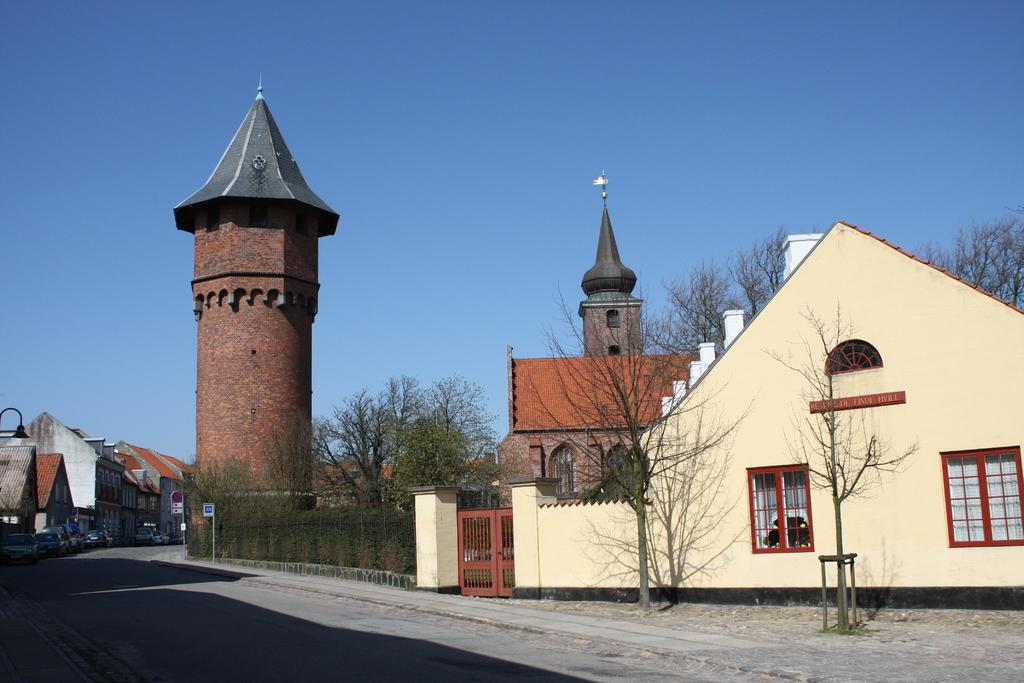What type of structures can be seen in the image? There are many buildings in the image. What is located at the bottom of the image? There is a road at the bottom of the image. What natural element is visible in the image? There is water visible in the image. What type of vegetation can be seen in the image? There are trees in the image. Where are the cars parked in the image? Cars are parked on the road on the left side of the image. Can you tell me how many gravestones are present in the image? There is no cemetery or gravestones present in the image. What type of bait is being used by the fisherman in the image? There is no fisherman or bait present in the image. 